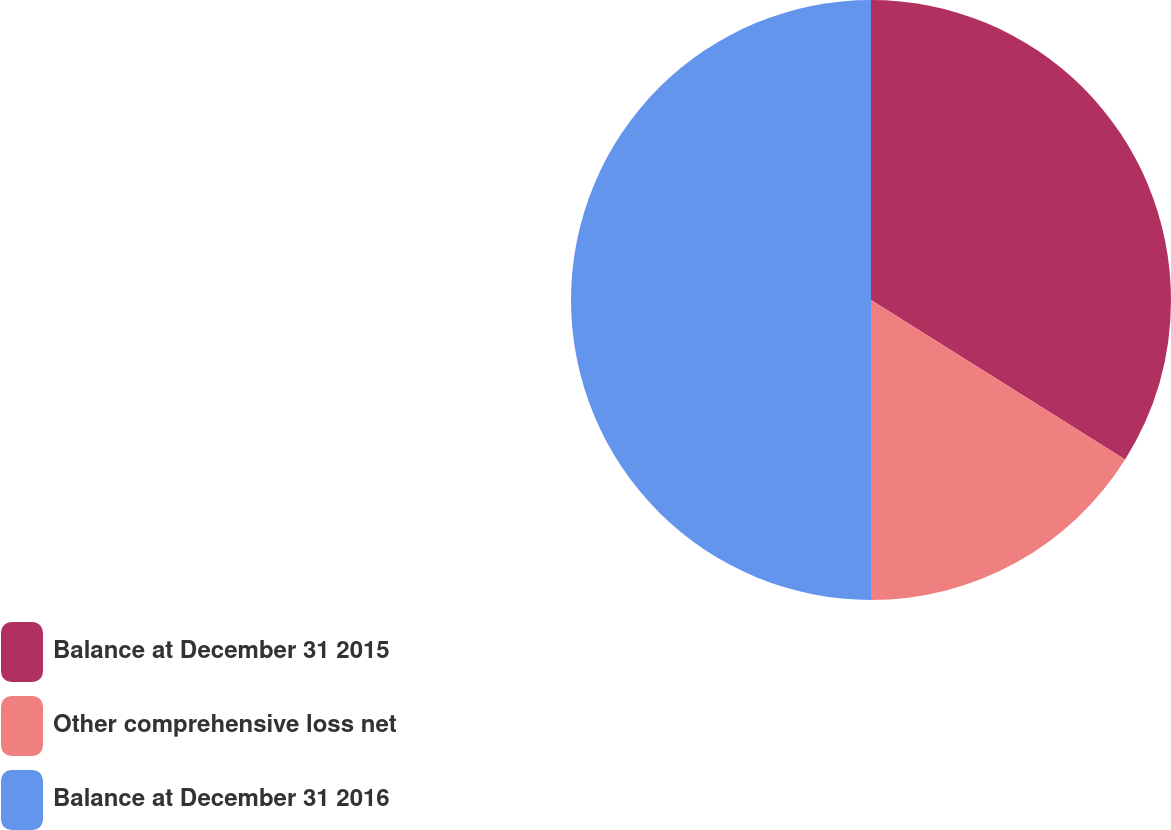Convert chart. <chart><loc_0><loc_0><loc_500><loc_500><pie_chart><fcel>Balance at December 31 2015<fcel>Other comprehensive loss net<fcel>Balance at December 31 2016<nl><fcel>33.92%<fcel>16.08%<fcel>50.0%<nl></chart> 